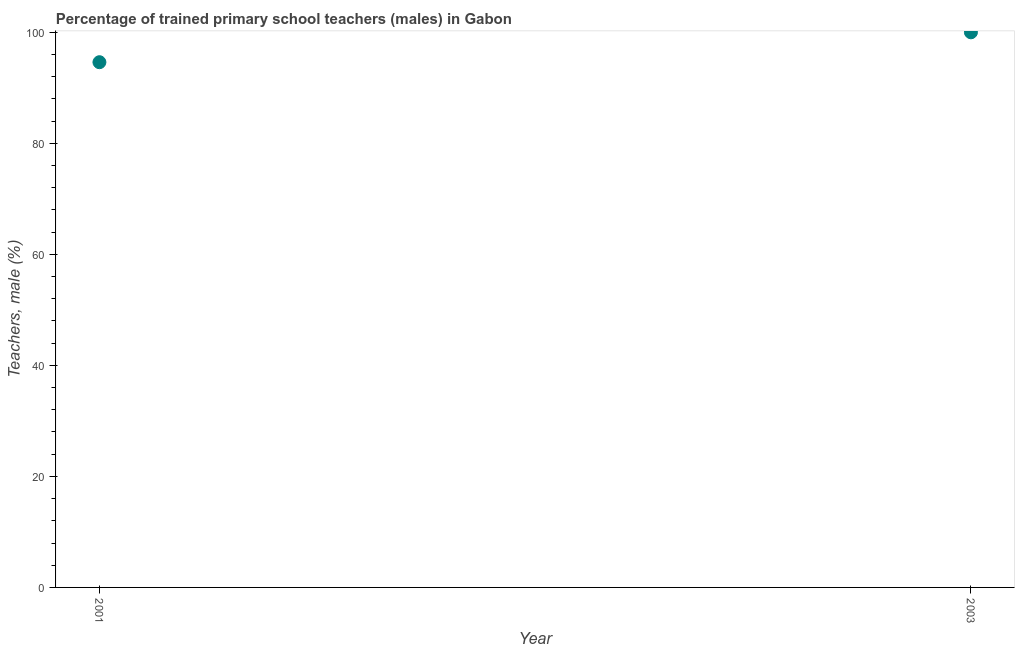Across all years, what is the maximum percentage of trained male teachers?
Keep it short and to the point. 100. Across all years, what is the minimum percentage of trained male teachers?
Make the answer very short. 94.62. In which year was the percentage of trained male teachers minimum?
Offer a very short reply. 2001. What is the sum of the percentage of trained male teachers?
Your answer should be very brief. 194.62. What is the difference between the percentage of trained male teachers in 2001 and 2003?
Keep it short and to the point. -5.38. What is the average percentage of trained male teachers per year?
Your answer should be compact. 97.31. What is the median percentage of trained male teachers?
Your answer should be compact. 97.31. In how many years, is the percentage of trained male teachers greater than 8 %?
Your answer should be very brief. 2. Do a majority of the years between 2003 and 2001 (inclusive) have percentage of trained male teachers greater than 36 %?
Provide a succinct answer. No. What is the ratio of the percentage of trained male teachers in 2001 to that in 2003?
Your response must be concise. 0.95. Is the percentage of trained male teachers in 2001 less than that in 2003?
Offer a very short reply. Yes. How many years are there in the graph?
Offer a terse response. 2. Are the values on the major ticks of Y-axis written in scientific E-notation?
Your answer should be very brief. No. Does the graph contain any zero values?
Your answer should be very brief. No. What is the title of the graph?
Ensure brevity in your answer.  Percentage of trained primary school teachers (males) in Gabon. What is the label or title of the Y-axis?
Ensure brevity in your answer.  Teachers, male (%). What is the Teachers, male (%) in 2001?
Provide a succinct answer. 94.62. What is the difference between the Teachers, male (%) in 2001 and 2003?
Your answer should be very brief. -5.38. What is the ratio of the Teachers, male (%) in 2001 to that in 2003?
Offer a very short reply. 0.95. 